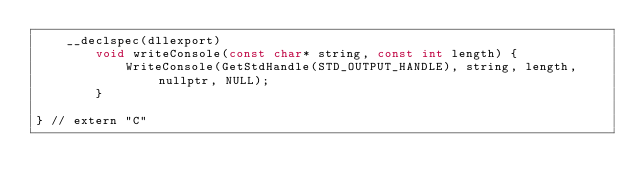<code> <loc_0><loc_0><loc_500><loc_500><_C++_>	__declspec(dllexport)
		void writeConsole(const char* string, const int length) {
			WriteConsole(GetStdHandle(STD_OUTPUT_HANDLE), string, length, nullptr, NULL);
		}

} // extern "C"
</code> 